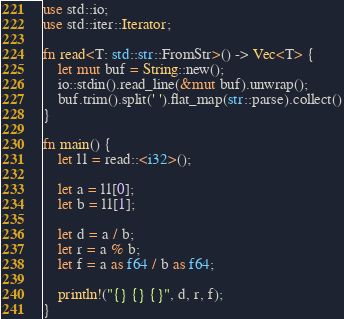<code> <loc_0><loc_0><loc_500><loc_500><_Rust_>use std::io;
use std::iter::Iterator;

fn read<T: std::str::FromStr>() -> Vec<T> {
    let mut buf = String::new();
    io::stdin().read_line(&mut buf).unwrap();
    buf.trim().split(' ').flat_map(str::parse).collect()
}

fn main() {
    let l1 = read::<i32>();

    let a = l1[0];
    let b = l1[1];

    let d = a / b;
    let r = a % b;
    let f = a as f64 / b as f64;

    println!("{} {} {}", d, r, f);
}

</code> 